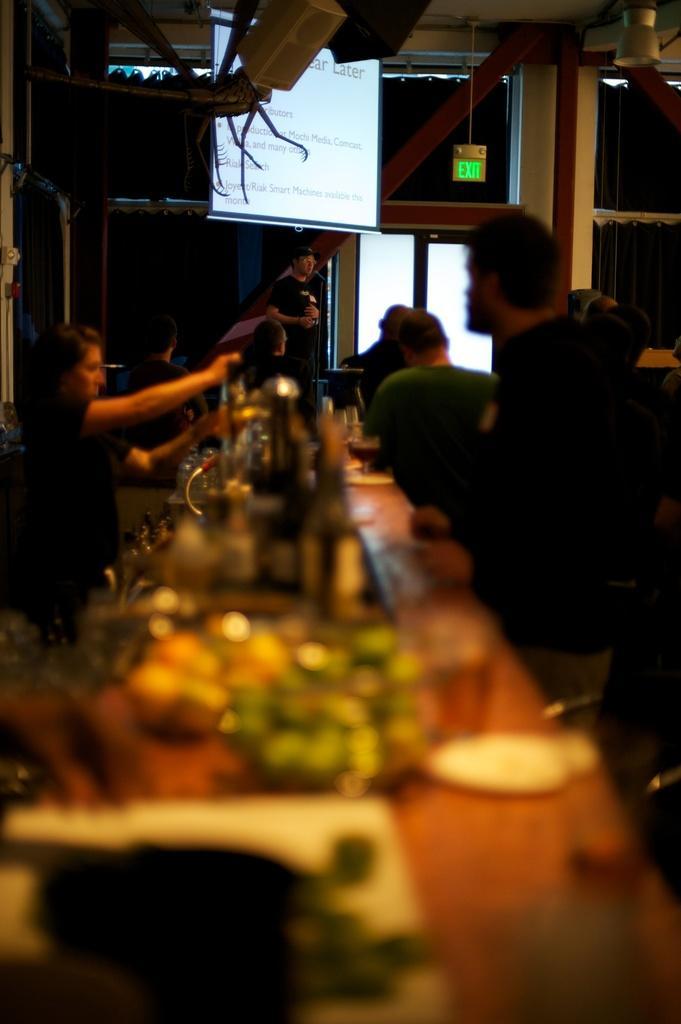In one or two sentences, can you explain what this image depicts? In this image there are few people standing in front of the table. On the table there are some objects and there is a glass. At the back side the person is standing and there is a screen and a window. 